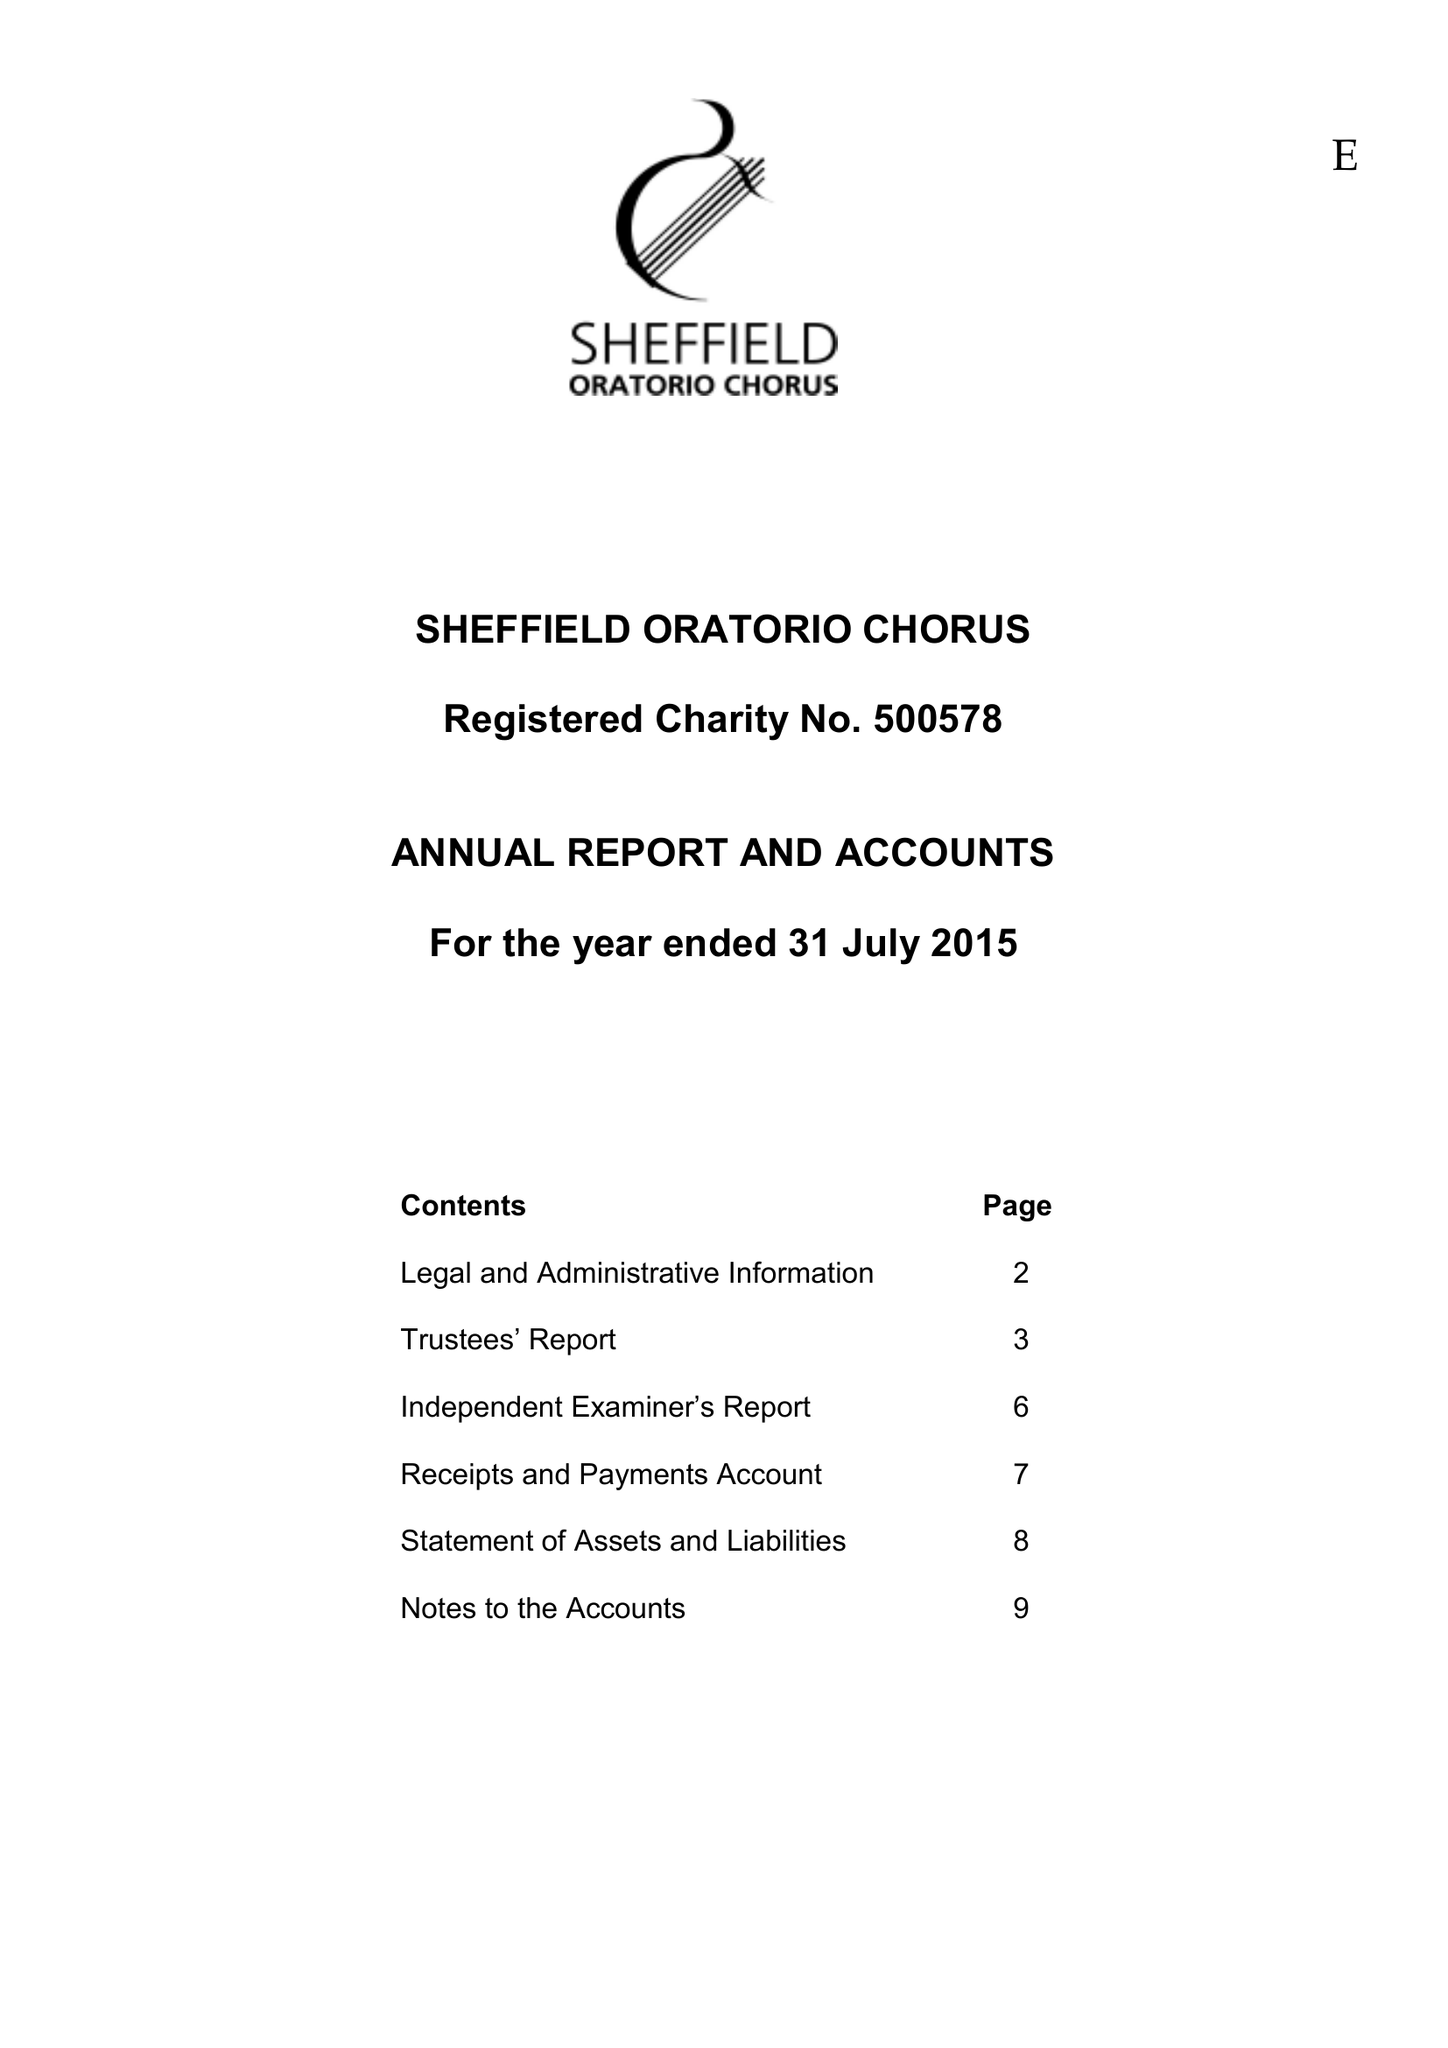What is the value for the address__post_town?
Answer the question using a single word or phrase. HOLMFIRTH 